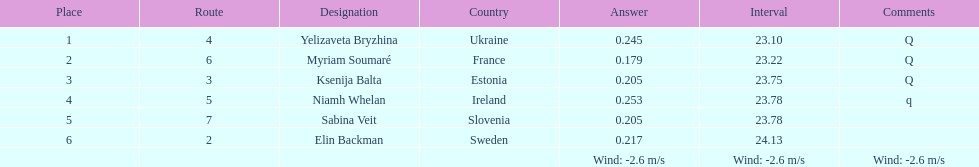Who finished after sabina veit? Elin Backman. 